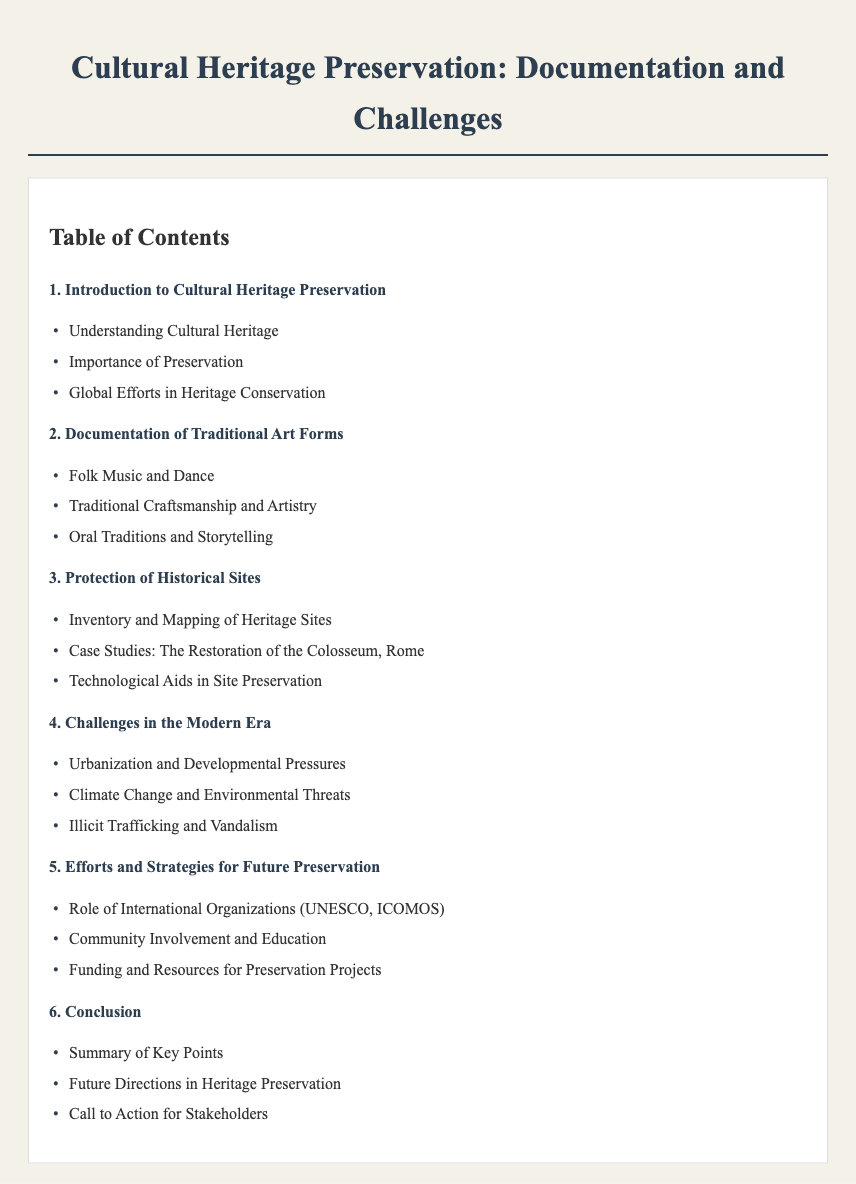What is the first chapter about? The first chapter introduces the topic of cultural heritage preservation and its significance.
Answer: Introduction to Cultural Heritage Preservation How many sections are there in chapter 2? Chapter 2 includes three sections related to traditional art forms.
Answer: 3 Which organization is mentioned in the preservation efforts? The document highlights the role of international organizations involved in cultural heritage preservation.
Answer: UNESCO What is a challenge mentioned in chapter 4? Chapter 4 outlines the challenges faced in modern times regarding preservation.
Answer: Urbanization and Developmental Pressures What is the last section in chapter 6? The final section summarizes the document's key points and future directions.
Answer: Call to Action for Stakeholders 